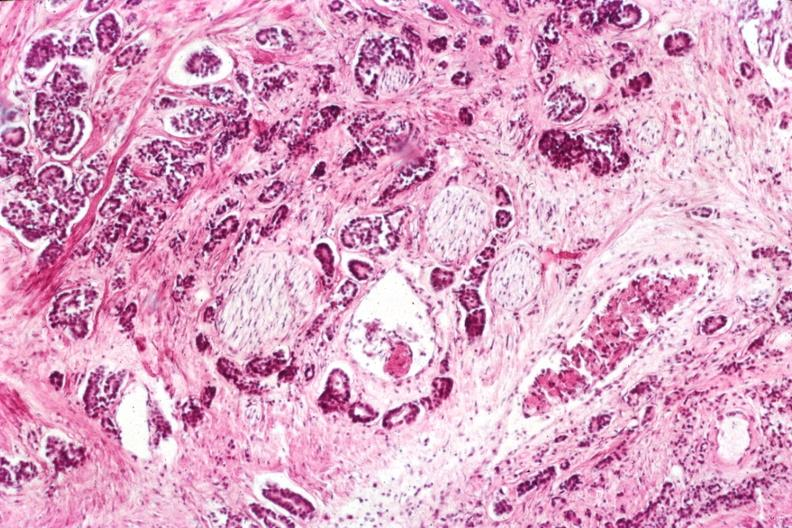what is present?
Answer the question using a single word or phrase. Adenocarcinoma 